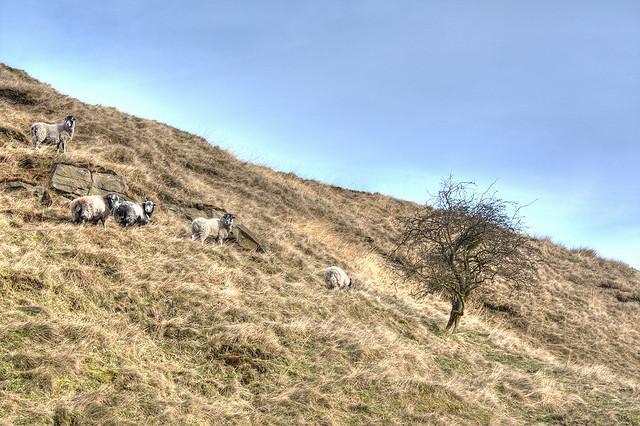How many trees are in the image?
Give a very brief answer. 1. How many people are surf boards are in this picture?
Give a very brief answer. 0. 